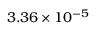Convert formula to latex. <formula><loc_0><loc_0><loc_500><loc_500>3 . 3 6 \times 1 0 ^ { - 5 }</formula> 